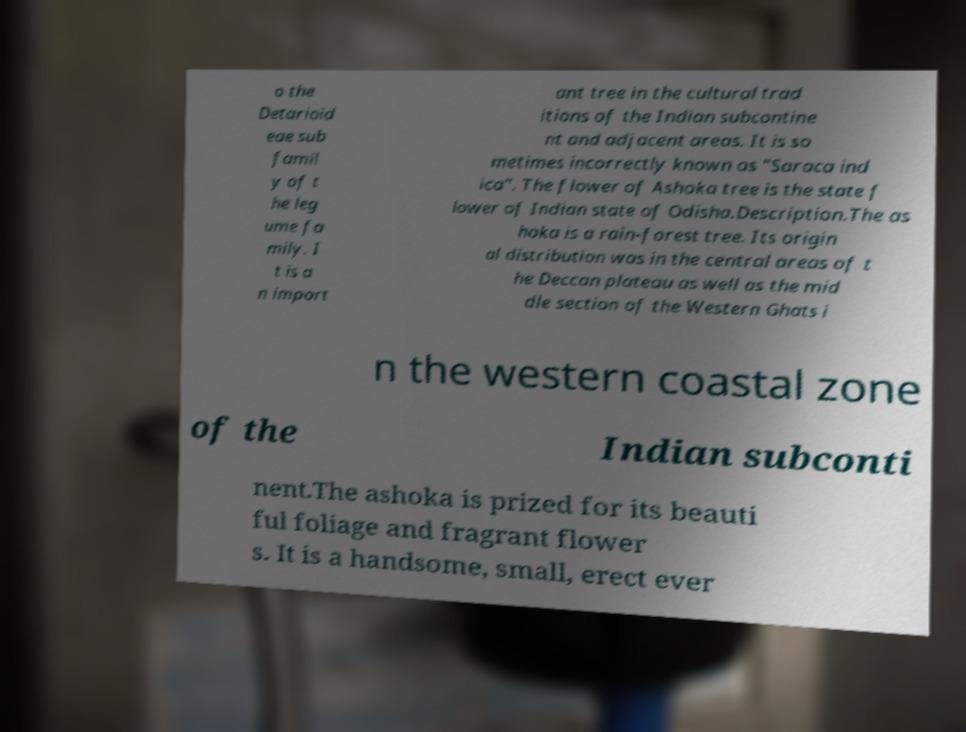There's text embedded in this image that I need extracted. Can you transcribe it verbatim? o the Detarioid eae sub famil y of t he leg ume fa mily. I t is a n import ant tree in the cultural trad itions of the Indian subcontine nt and adjacent areas. It is so metimes incorrectly known as "Saraca ind ica". The flower of Ashoka tree is the state f lower of Indian state of Odisha.Description.The as hoka is a rain-forest tree. Its origin al distribution was in the central areas of t he Deccan plateau as well as the mid dle section of the Western Ghats i n the western coastal zone of the Indian subconti nent.The ashoka is prized for its beauti ful foliage and fragrant flower s. It is a handsome, small, erect ever 